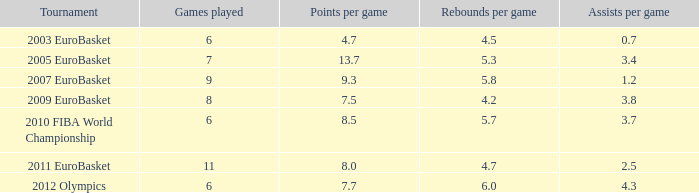How many points per game have the tournament 2005 eurobasket? 13.7. 